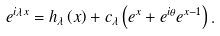Convert formula to latex. <formula><loc_0><loc_0><loc_500><loc_500>e ^ { i \lambda x } = h _ { \lambda } \left ( x \right ) + c _ { \lambda } \left ( e ^ { x } + e ^ { i \theta } e ^ { x - 1 } \right ) .</formula> 